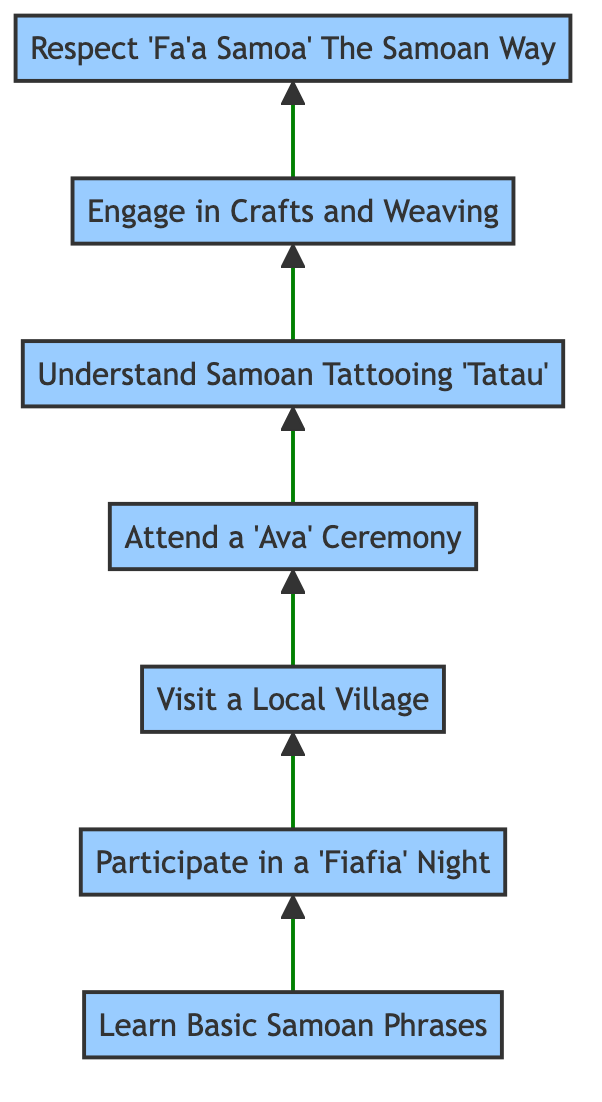What is the first step in the cultural immersion process? The bottom node of the flow chart, which is the starting point, represents the first step. It is labeled "Learn Basic Samoan Phrases."
Answer: Learn Basic Samoan Phrases How many steps are in the cultural immersion flow chart? By counting the nodes in the diagram from bottom to top, there are seven distinct steps listed in the flow chart.
Answer: 7 What is the last step in the diagram? The top node, which concludes the flow chart, represents the final step. It is labeled "Respect 'Fa'a Samoa' (The Samoan Way)."
Answer: Respect 'Fa'a Samoa' (The Samoan Way) What step follows 'Participate in a Fiafia Night'? The diagram indicates a direct connection where the step immediately after 'Participate in a Fiafia Night' is 'Visit a Local Village.'
Answer: Visit a Local Village Which step involves experiencing the traditional kava ceremony? By examining the flow of steps, it is evident that the step that involves the kava ceremony is labeled 'Attend a 'Ava' Ceremony.'
Answer: Attend a 'Ava' Ceremony What is the relation between 'Engage in Crafts and Weaving' and 'Understand Samoan Tattooing (Tatau)'? The diagram shows an upward connection indicating that 'Engage in Crafts and Weaving' follows 'Understand Samoan Tattooing (Tatau),' meaning participants should learn about tattoos before engaging in crafts.
Answer: Engage in Crafts and Weaving follows Understand Samoan Tattooing (Tatau) Which step precedes visiting a local village? By checking the flow upward from 'Visit a Local Village,' the previous step is 'Participate in a Fiafia Night.'
Answer: Participate in a Fiafia Night What is the second to last step before respecting 'Fa'a Samoa'? The step just before the top node (last step) is 'Engage in Crafts and Weaving,' which is the second to last step in the diagram.
Answer: Engage in Crafts and Weaving 